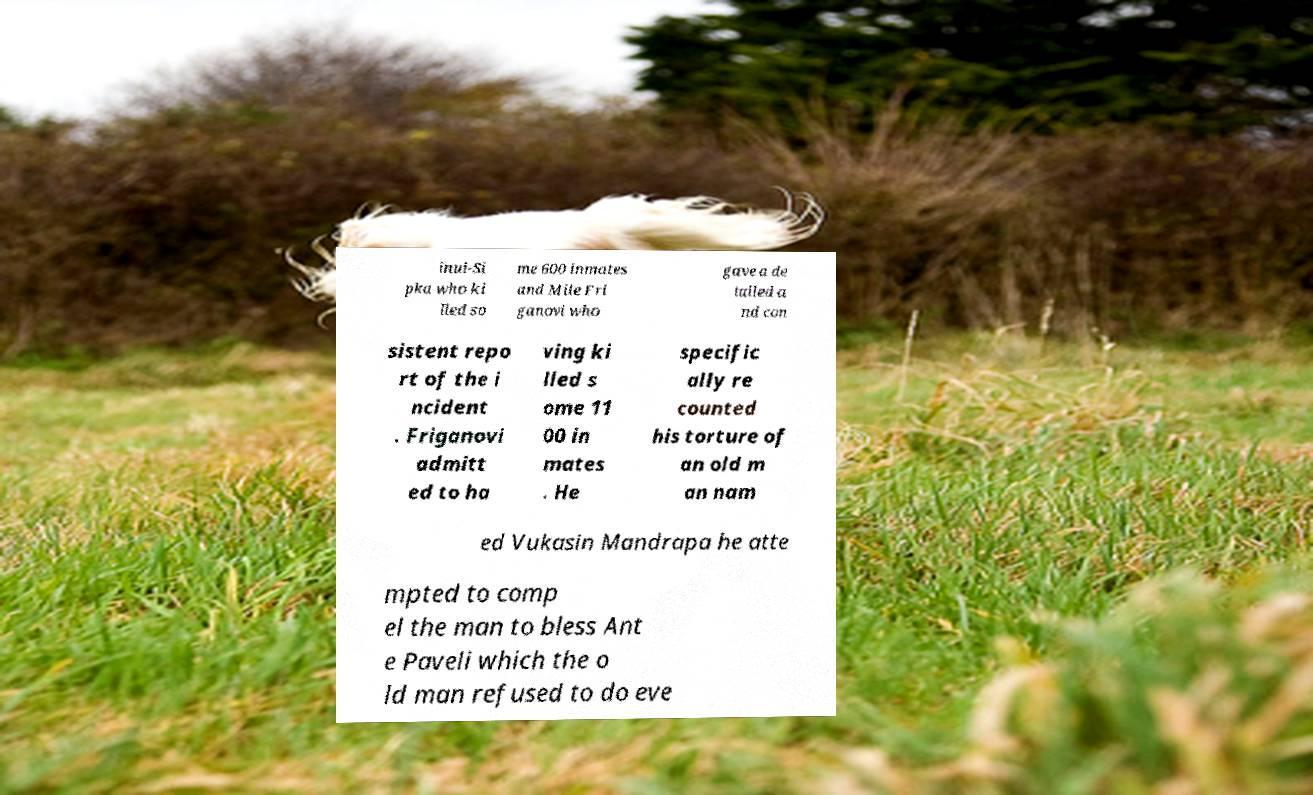There's text embedded in this image that I need extracted. Can you transcribe it verbatim? inui-Si pka who ki lled so me 600 inmates and Mile Fri ganovi who gave a de tailed a nd con sistent repo rt of the i ncident . Friganovi admitt ed to ha ving ki lled s ome 11 00 in mates . He specific ally re counted his torture of an old m an nam ed Vukasin Mandrapa he atte mpted to comp el the man to bless Ant e Paveli which the o ld man refused to do eve 